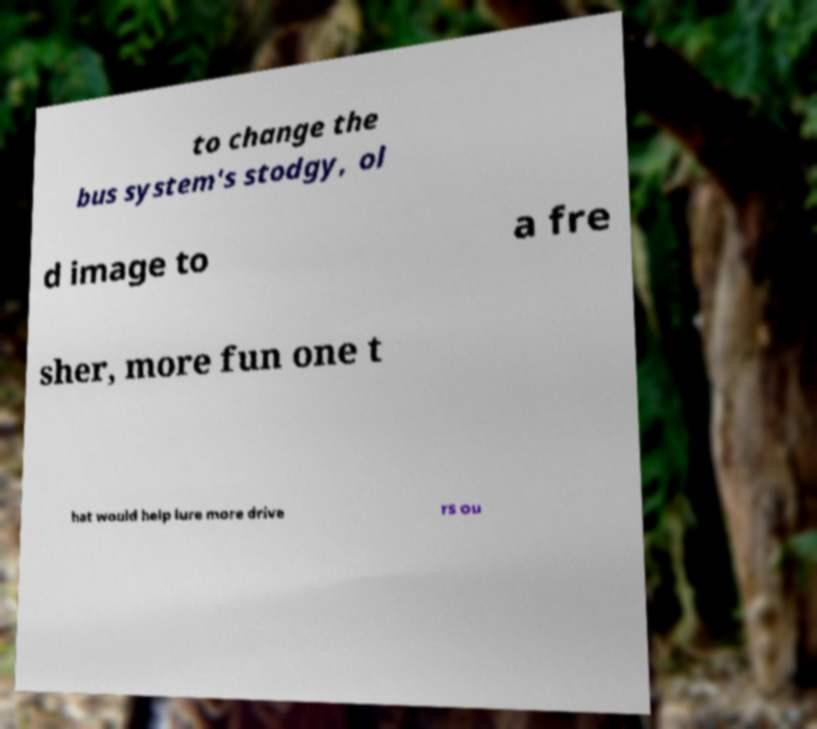Could you assist in decoding the text presented in this image and type it out clearly? to change the bus system's stodgy, ol d image to a fre sher, more fun one t hat would help lure more drive rs ou 